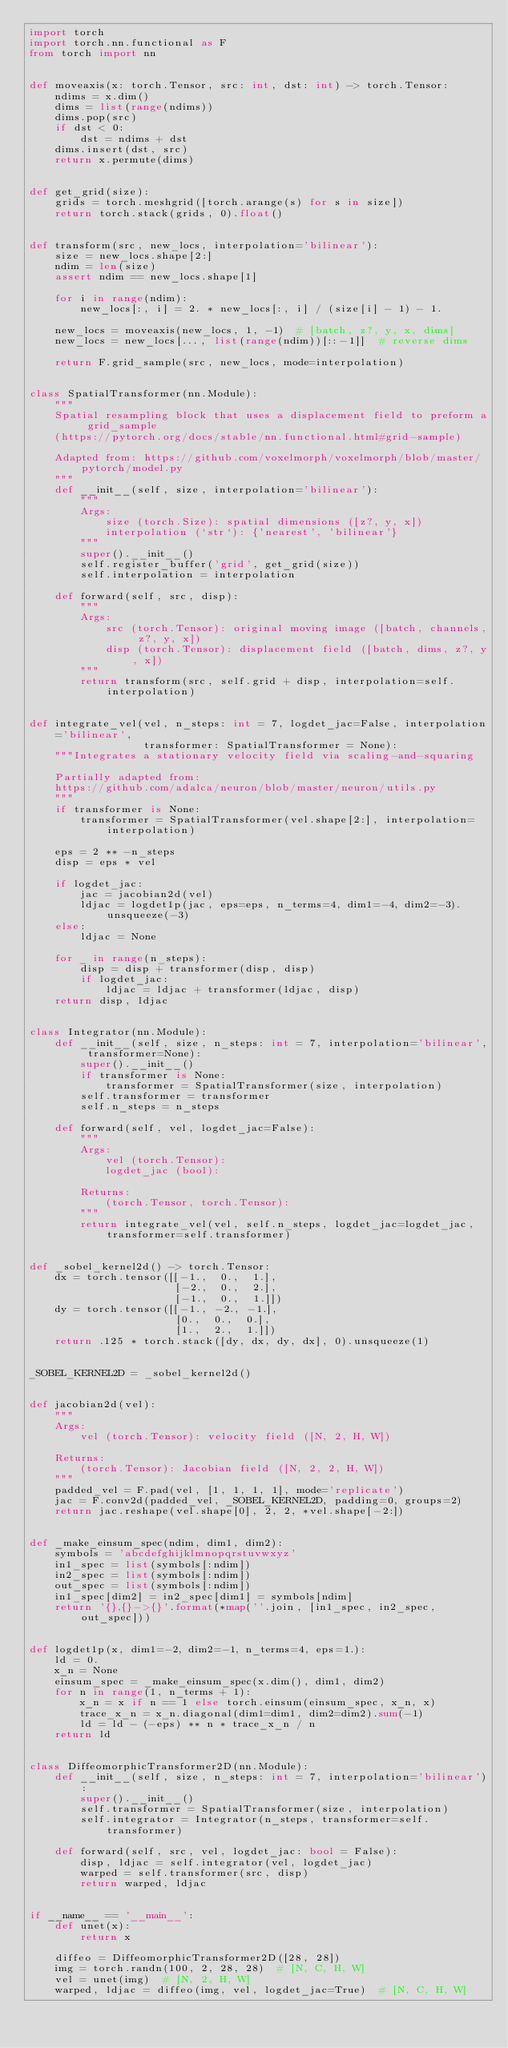Convert code to text. <code><loc_0><loc_0><loc_500><loc_500><_Python_>import torch
import torch.nn.functional as F
from torch import nn


def moveaxis(x: torch.Tensor, src: int, dst: int) -> torch.Tensor:
    ndims = x.dim()
    dims = list(range(ndims))
    dims.pop(src)
    if dst < 0:
        dst = ndims + dst
    dims.insert(dst, src)
    return x.permute(dims)


def get_grid(size):
    grids = torch.meshgrid([torch.arange(s) for s in size])
    return torch.stack(grids, 0).float()


def transform(src, new_locs, interpolation='bilinear'):
    size = new_locs.shape[2:]
    ndim = len(size)
    assert ndim == new_locs.shape[1]

    for i in range(ndim):
        new_locs[:, i] = 2. * new_locs[:, i] / (size[i] - 1) - 1.

    new_locs = moveaxis(new_locs, 1, -1)  # [batch, z?, y, x, dims]
    new_locs = new_locs[..., list(range(ndim))[::-1]]  # reverse dims

    return F.grid_sample(src, new_locs, mode=interpolation)


class SpatialTransformer(nn.Module):
    """
    Spatial resampling block that uses a displacement field to preform a grid_sample
    (https://pytorch.org/docs/stable/nn.functional.html#grid-sample)

    Adapted from: https://github.com/voxelmorph/voxelmorph/blob/master/pytorch/model.py
    """
    def __init__(self, size, interpolation='bilinear'):
        """
        Args:
            size (torch.Size): spatial dimensions ([z?, y, x])
            interpolation (`str`): {'nearest', 'bilinear'}
        """
        super().__init__()
        self.register_buffer('grid', get_grid(size))
        self.interpolation = interpolation

    def forward(self, src, disp):
        """
        Args:
            src (torch.Tensor): original moving image ([batch, channels, z?, y, x])
            disp (torch.Tensor): displacement field ([batch, dims, z?, y, x])
        """
        return transform(src, self.grid + disp, interpolation=self.interpolation)


def integrate_vel(vel, n_steps: int = 7, logdet_jac=False, interpolation='bilinear',
                  transformer: SpatialTransformer = None):
    """Integrates a stationary velocity field via scaling-and-squaring

    Partially adapted from:
    https://github.com/adalca/neuron/blob/master/neuron/utils.py
    """
    if transformer is None:
        transformer = SpatialTransformer(vel.shape[2:], interpolation=interpolation)

    eps = 2 ** -n_steps
    disp = eps * vel

    if logdet_jac:
        jac = jacobian2d(vel)
        ldjac = logdet1p(jac, eps=eps, n_terms=4, dim1=-4, dim2=-3).unsqueeze(-3)
    else:
        ldjac = None

    for _ in range(n_steps):
        disp = disp + transformer(disp, disp)
        if logdet_jac:
            ldjac = ldjac + transformer(ldjac, disp)
    return disp, ldjac


class Integrator(nn.Module):
    def __init__(self, size, n_steps: int = 7, interpolation='bilinear', transformer=None):
        super().__init__()
        if transformer is None:
            transformer = SpatialTransformer(size, interpolation)
        self.transformer = transformer
        self.n_steps = n_steps

    def forward(self, vel, logdet_jac=False):
        """
        Args:
            vel (torch.Tensor):
            logdet_jac (bool):

        Returns:
            (torch.Tensor, torch.Tensor):
        """
        return integrate_vel(vel, self.n_steps, logdet_jac=logdet_jac, transformer=self.transformer)


def _sobel_kernel2d() -> torch.Tensor:
    dx = torch.tensor([[-1.,  0.,  1.],
                       [-2.,  0.,  2.],
                       [-1.,  0.,  1.]])
    dy = torch.tensor([[-1., -2., -1.],
                       [0.,  0.,  0.],
                       [1.,  2.,  1.]])
    return .125 * torch.stack([dy, dx, dy, dx], 0).unsqueeze(1)


_SOBEL_KERNEL2D = _sobel_kernel2d()


def jacobian2d(vel):
    """
    Args:
        vel (torch.Tensor): velocity field ([N, 2, H, W])

    Returns:
        (torch.Tensor): Jacobian field ([N, 2, 2, H, W])
    """
    padded_vel = F.pad(vel, [1, 1, 1, 1], mode='replicate')
    jac = F.conv2d(padded_vel, _SOBEL_KERNEL2D, padding=0, groups=2)
    return jac.reshape(vel.shape[0], 2, 2, *vel.shape[-2:])


def _make_einsum_spec(ndim, dim1, dim2):
    symbols = 'abcdefghijklmnopqrstuvwxyz'
    in1_spec = list(symbols[:ndim])
    in2_spec = list(symbols[:ndim])
    out_spec = list(symbols[:ndim])
    in1_spec[dim2] = in2_spec[dim1] = symbols[ndim]
    return '{},{}->{}'.format(*map(''.join, [in1_spec, in2_spec, out_spec]))


def logdet1p(x, dim1=-2, dim2=-1, n_terms=4, eps=1.):
    ld = 0.
    x_n = None
    einsum_spec = _make_einsum_spec(x.dim(), dim1, dim2)
    for n in range(1, n_terms + 1):
        x_n = x if n == 1 else torch.einsum(einsum_spec, x_n, x)
        trace_x_n = x_n.diagonal(dim1=dim1, dim2=dim2).sum(-1)
        ld = ld - (-eps) ** n * trace_x_n / n
    return ld


class DiffeomorphicTransformer2D(nn.Module):
    def __init__(self, size, n_steps: int = 7, interpolation='bilinear'):
        super().__init__()
        self.transformer = SpatialTransformer(size, interpolation)
        self.integrator = Integrator(n_steps, transformer=self.transformer)

    def forward(self, src, vel, logdet_jac: bool = False):
        disp, ldjac = self.integrator(vel, logdet_jac)
        warped = self.transformer(src, disp)
        return warped, ldjac


if __name__ == '__main__':
    def unet(x):
        return x

    diffeo = DiffeomorphicTransformer2D([28, 28])
    img = torch.randn(100, 2, 28, 28)  # [N, C, H, W]
    vel = unet(img)  # [N, 2, H, W]
    warped, ldjac = diffeo(img, vel, logdet_jac=True)  # [N, C, H, W]
</code> 